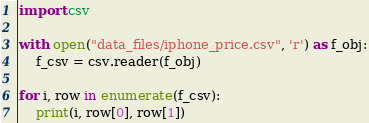Convert code to text. <code><loc_0><loc_0><loc_500><loc_500><_Python_>import csv

with open("data_files/iphone_price.csv", 'r') as f_obj:
	f_csv = csv.reader(f_obj)

for i, row in enumerate(f_csv):
	print(i, row[0], row[1])
</code> 